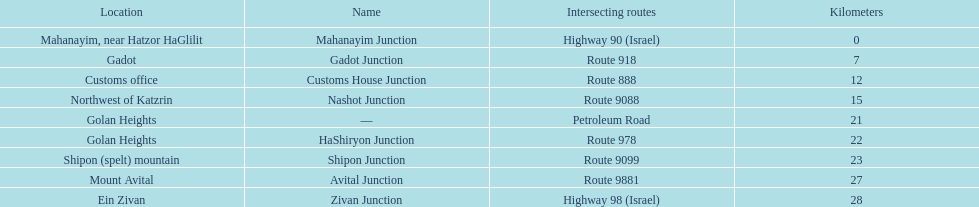What is the total kilometers that separates the mahanayim junction and the shipon junction? 23. 